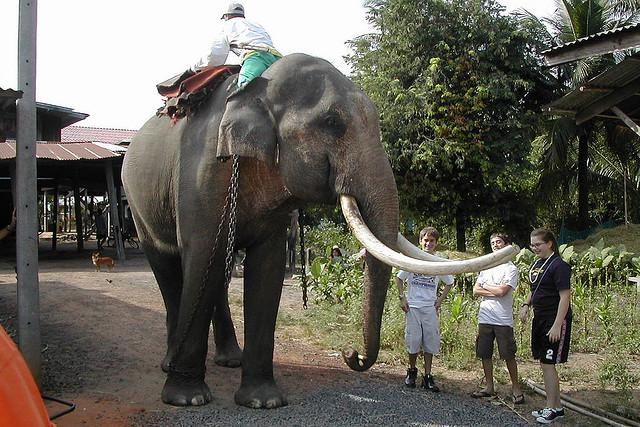Why is it unusual for elephants to have tusks this big?

Choices:
A) attracts poachers
B) grooming habits
C) impossibility
D) abnormality attracts poachers 